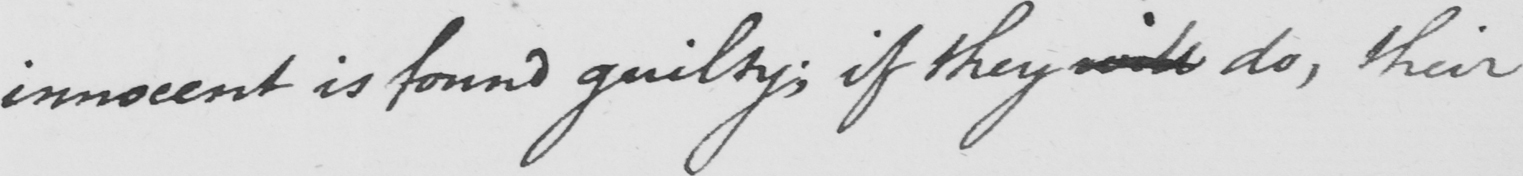Please provide the text content of this handwritten line. innocent is found guilty ; if they will do , their 